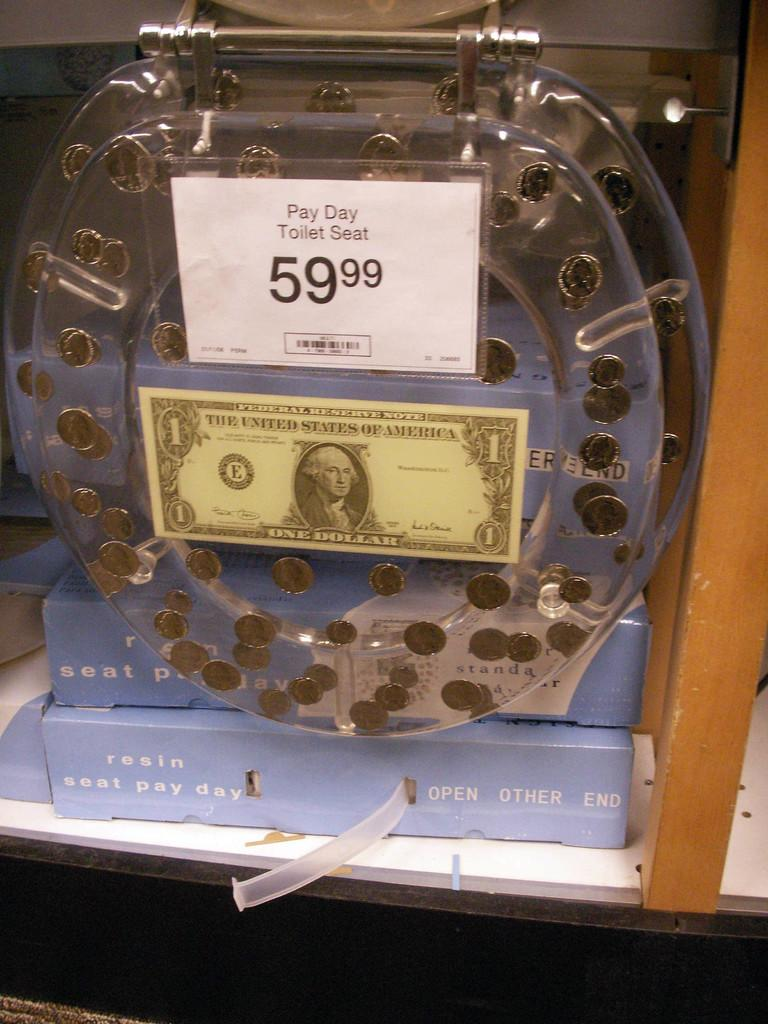<image>
Present a compact description of the photo's key features. A toilet seat has a price tag for 59.99 on it and a one dollar bill attached. 